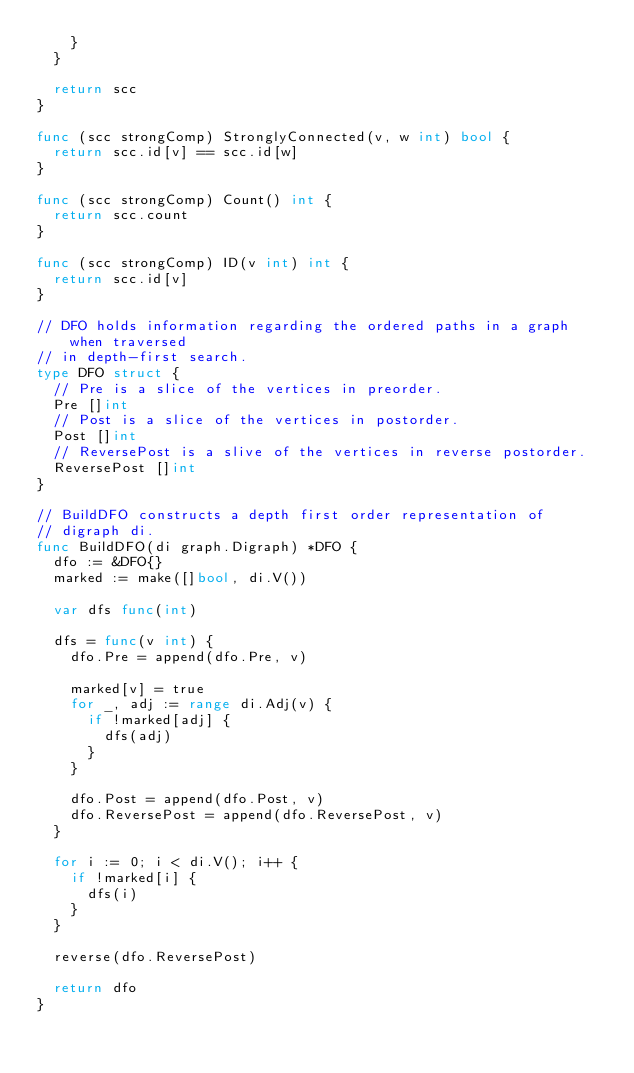<code> <loc_0><loc_0><loc_500><loc_500><_Go_>		}
	}

	return scc
}

func (scc strongComp) StronglyConnected(v, w int) bool {
	return scc.id[v] == scc.id[w]
}

func (scc strongComp) Count() int {
	return scc.count
}

func (scc strongComp) ID(v int) int {
	return scc.id[v]
}

// DFO holds information regarding the ordered paths in a graph when traversed
// in depth-first search.
type DFO struct {
	// Pre is a slice of the vertices in preorder.
	Pre []int
	// Post is a slice of the vertices in postorder.
	Post []int
	// ReversePost is a slive of the vertices in reverse postorder.
	ReversePost []int
}

// BuildDFO constructs a depth first order representation of
// digraph di.
func BuildDFO(di graph.Digraph) *DFO {
	dfo := &DFO{}
	marked := make([]bool, di.V())

	var dfs func(int)

	dfs = func(v int) {
		dfo.Pre = append(dfo.Pre, v)

		marked[v] = true
		for _, adj := range di.Adj(v) {
			if !marked[adj] {
				dfs(adj)
			}
		}

		dfo.Post = append(dfo.Post, v)
		dfo.ReversePost = append(dfo.ReversePost, v)
	}

	for i := 0; i < di.V(); i++ {
		if !marked[i] {
			dfs(i)
		}
	}

	reverse(dfo.ReversePost)

	return dfo
}
</code> 